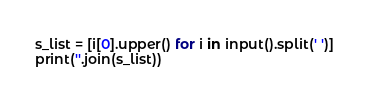<code> <loc_0><loc_0><loc_500><loc_500><_Python_>s_list = [i[0].upper() for i in input().split(' ')]
print(''.join(s_list))</code> 